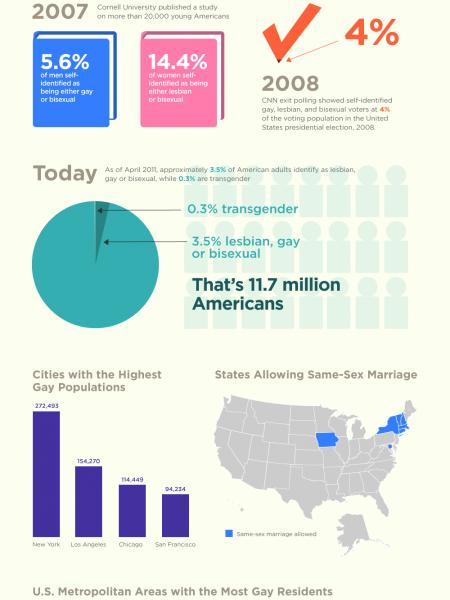Point out several critical features in this image. In the year 2007, a survey found that 14.4% of women identified as lesbian or bisexual. Chicago, a city in the United States, has the third highest number of gay people among all cities in the country. 